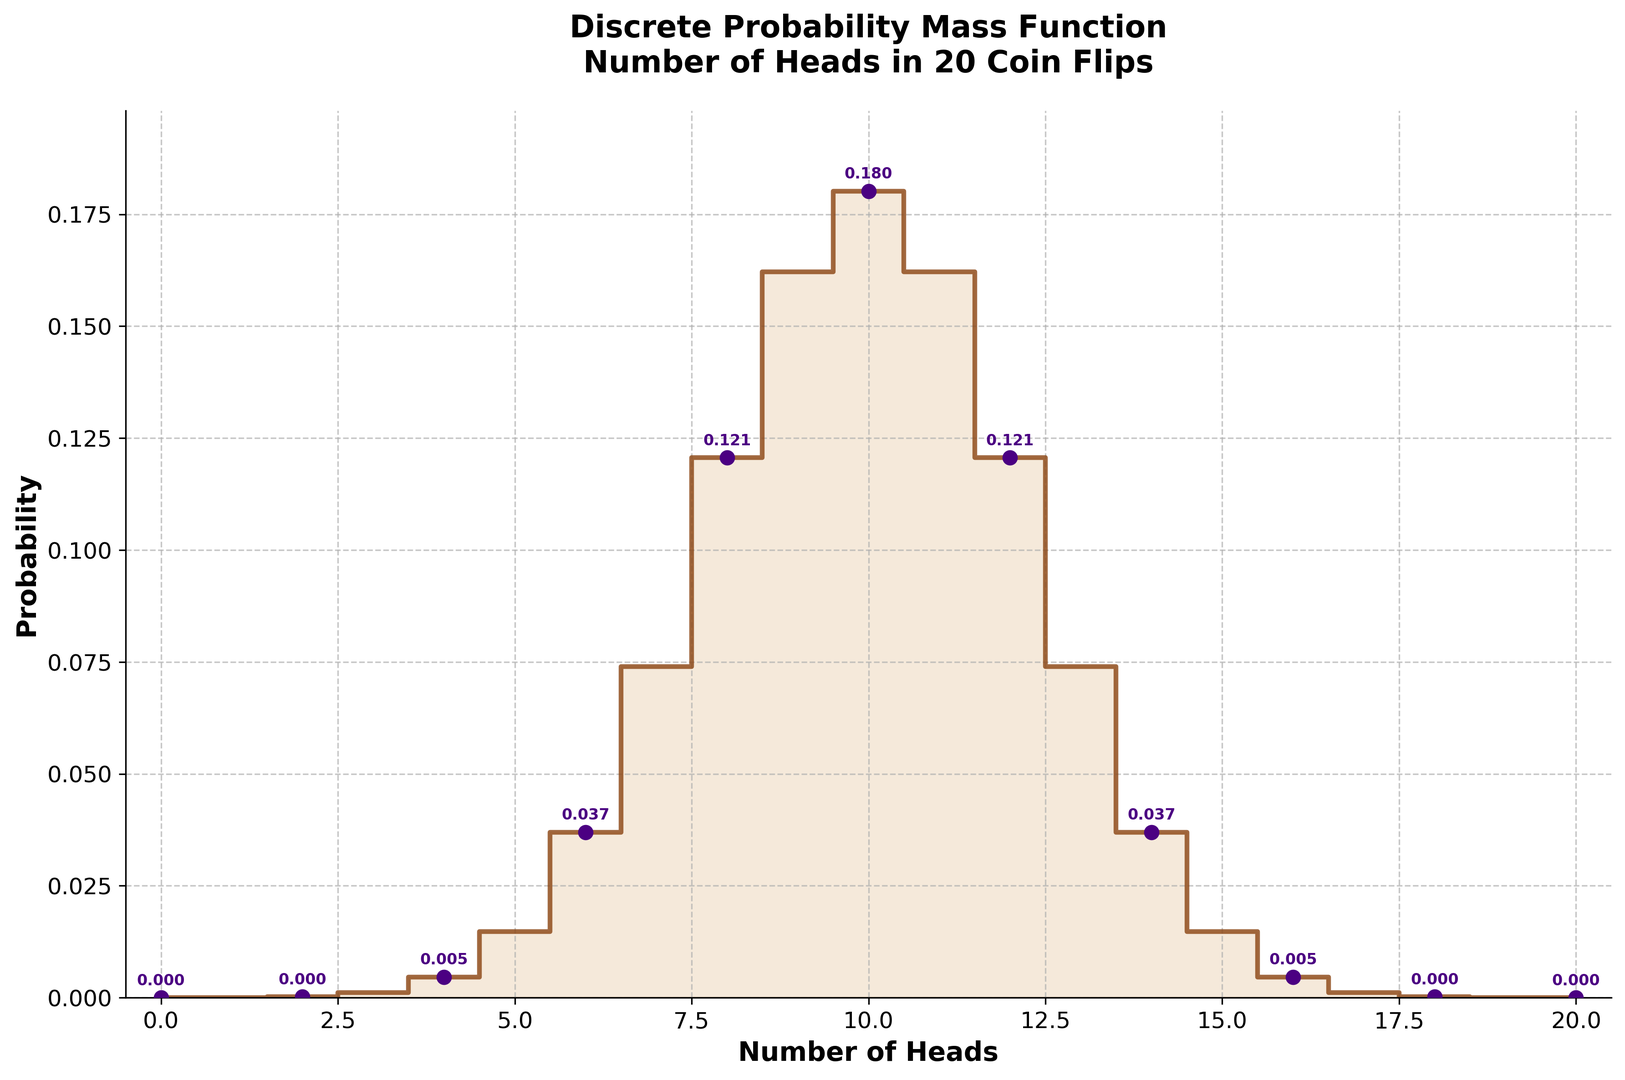what is the peak probability in the plot? The highest point on the plot represents the peak probability. We can visually observe that the peak occurs around the mid-range, specifically at `number_of_heads = 10`. The corresponding probability value at this peak is 0.180.
Answer: 0.180 Which outcome has the lowest probability? The outcomes with the lowest probability appear at the extreme ends of the x-axis (number of heads 0 and 20), corresponding to the minimum value on the y-axis. These probabilities are 0.000000954.
Answer: Outcomes 0 and 20 What's the difference in probability between getting 9 heads and getting 11 heads? To find the difference, we subtract the probability of getting 11 heads from the probability of getting 9 heads. From the plot, the probabilities are 0.162 (for 9 heads) and 0.162 (for 11 heads). The difference is therefore 0.162 - 0.162 = 0.
Answer: 0 Is getting 7 heads more likely than getting 13 heads? By comparing the heights of the steps for 7 heads and 13 heads on the plot, we see that the probability of getting 7 heads (0.0739) is higher than that of getting 13 heads (0.0739). Since these values are the same, they have equal likelihoods.
Answer: Equal likelihoods 